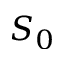Convert formula to latex. <formula><loc_0><loc_0><loc_500><loc_500>S _ { 0 }</formula> 